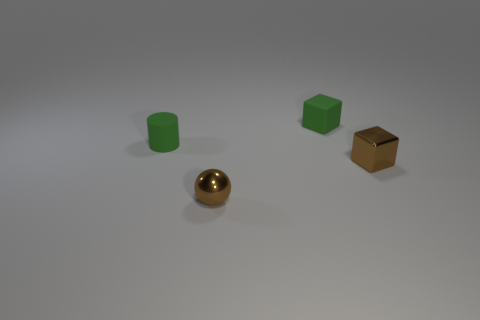Add 4 small rubber cylinders. How many objects exist? 8 Subtract all cylinders. How many objects are left? 3 Add 1 green cylinders. How many green cylinders are left? 2 Add 2 tiny green cubes. How many tiny green cubes exist? 3 Subtract 0 yellow cubes. How many objects are left? 4 Subtract all big matte things. Subtract all cubes. How many objects are left? 2 